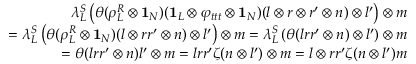Convert formula to latex. <formula><loc_0><loc_0><loc_500><loc_500>\begin{array} { r } { \lambda _ { L } ^ { S } \left ( \theta ( \rho _ { L } ^ { R } \otimes 1 _ { N } ) ( 1 _ { L } \otimes \varphi _ { t t t } \otimes 1 _ { N } ) ( l \otimes r \otimes r ^ { \prime } \otimes n ) \otimes l ^ { \prime } \right ) \otimes m } \\ { = \lambda _ { L } ^ { S } \left ( \theta ( \rho _ { L } ^ { R } \otimes 1 _ { N } ) ( l \otimes r r ^ { \prime } \otimes n ) \otimes l ^ { \prime } \right ) \otimes m = \lambda _ { L } ^ { S } \left ( \theta ( l r r ^ { \prime } \otimes n ) \otimes l ^ { \prime } \right ) \otimes m } \\ { = \theta ( l r r ^ { \prime } \otimes n ) l ^ { \prime } \otimes m = l r r ^ { \prime } \zeta ( n \otimes l ^ { \prime } ) \otimes m = l \otimes r r ^ { \prime } \zeta ( n \otimes l ^ { \prime } ) m } \end{array}</formula> 